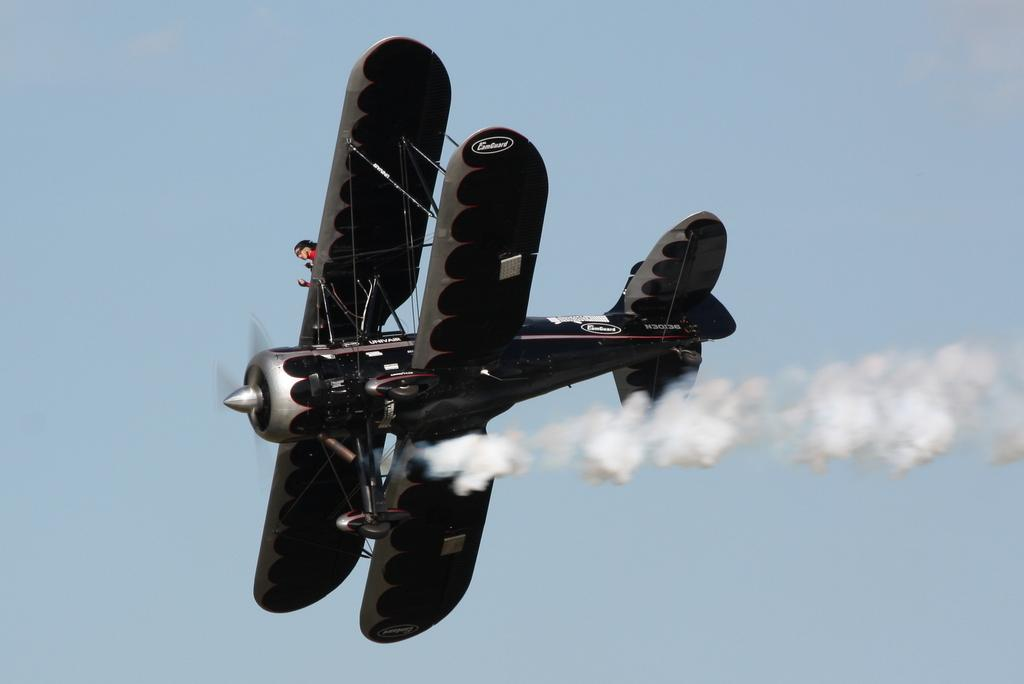Where was the picture taken? The picture was taken outside. What can be seen in the sky in the image? An aircraft is flying in the sky in the image. What is the aircraft doing in the image? The aircraft is releasing smoke in the image. Can you see any oranges growing near the aircraft in the image? There are no oranges visible in the image; it features an aircraft flying in the sky and releasing smoke. 